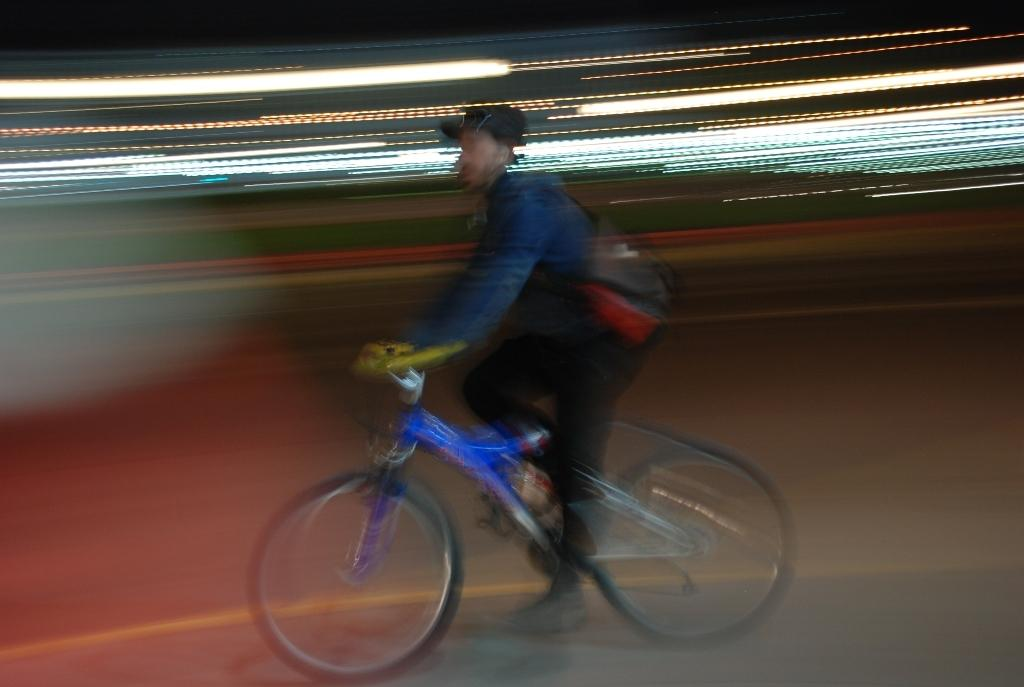What is the main subject of the image? There is a person in the image. What is the person doing in the image? The person is riding a cycle. Is the person carrying anything while riding the cycle? Yes, the person is wearing a bag. What type of plough is the person using in the image? There is no plough present in the image; the person is riding a cycle. How does the person blow air while riding the cycle in the image? The person is not blowing air in the image; they are simply riding the cycle. 